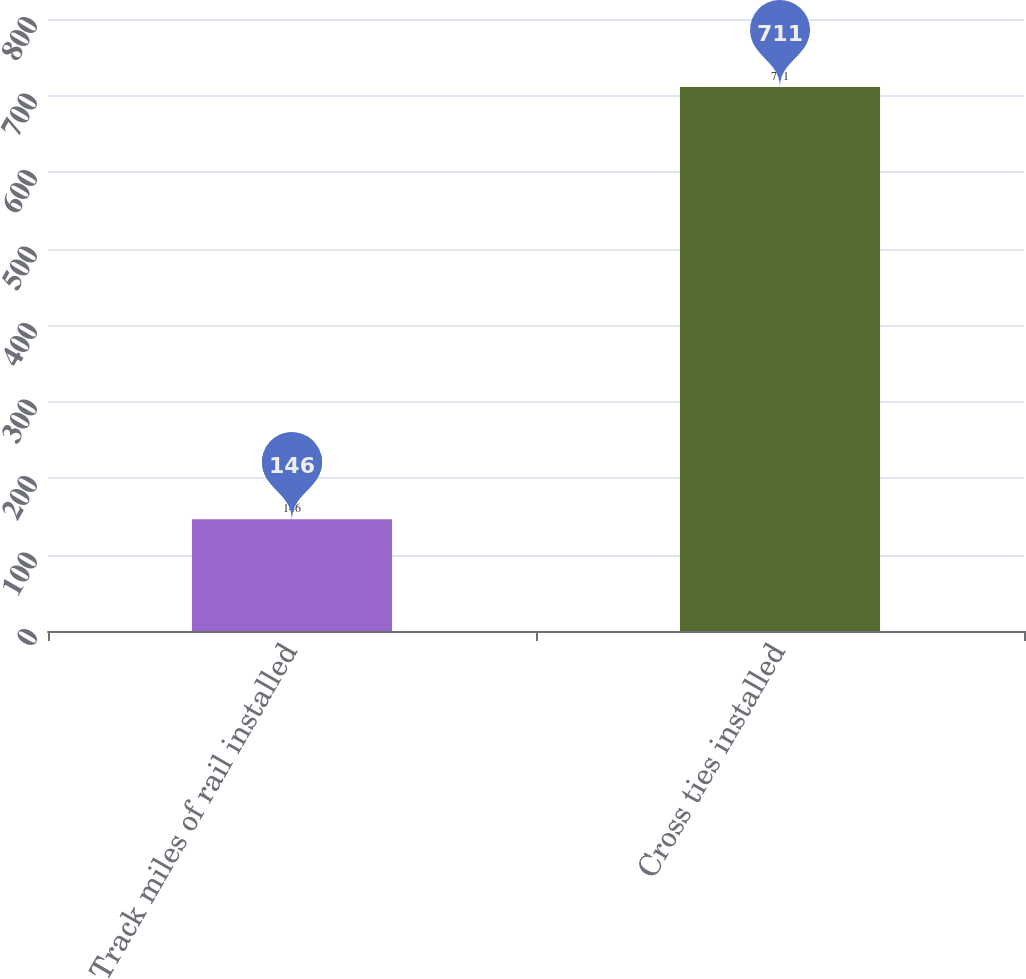<chart> <loc_0><loc_0><loc_500><loc_500><bar_chart><fcel>Track miles of rail installed<fcel>Cross ties installed<nl><fcel>146<fcel>711<nl></chart> 